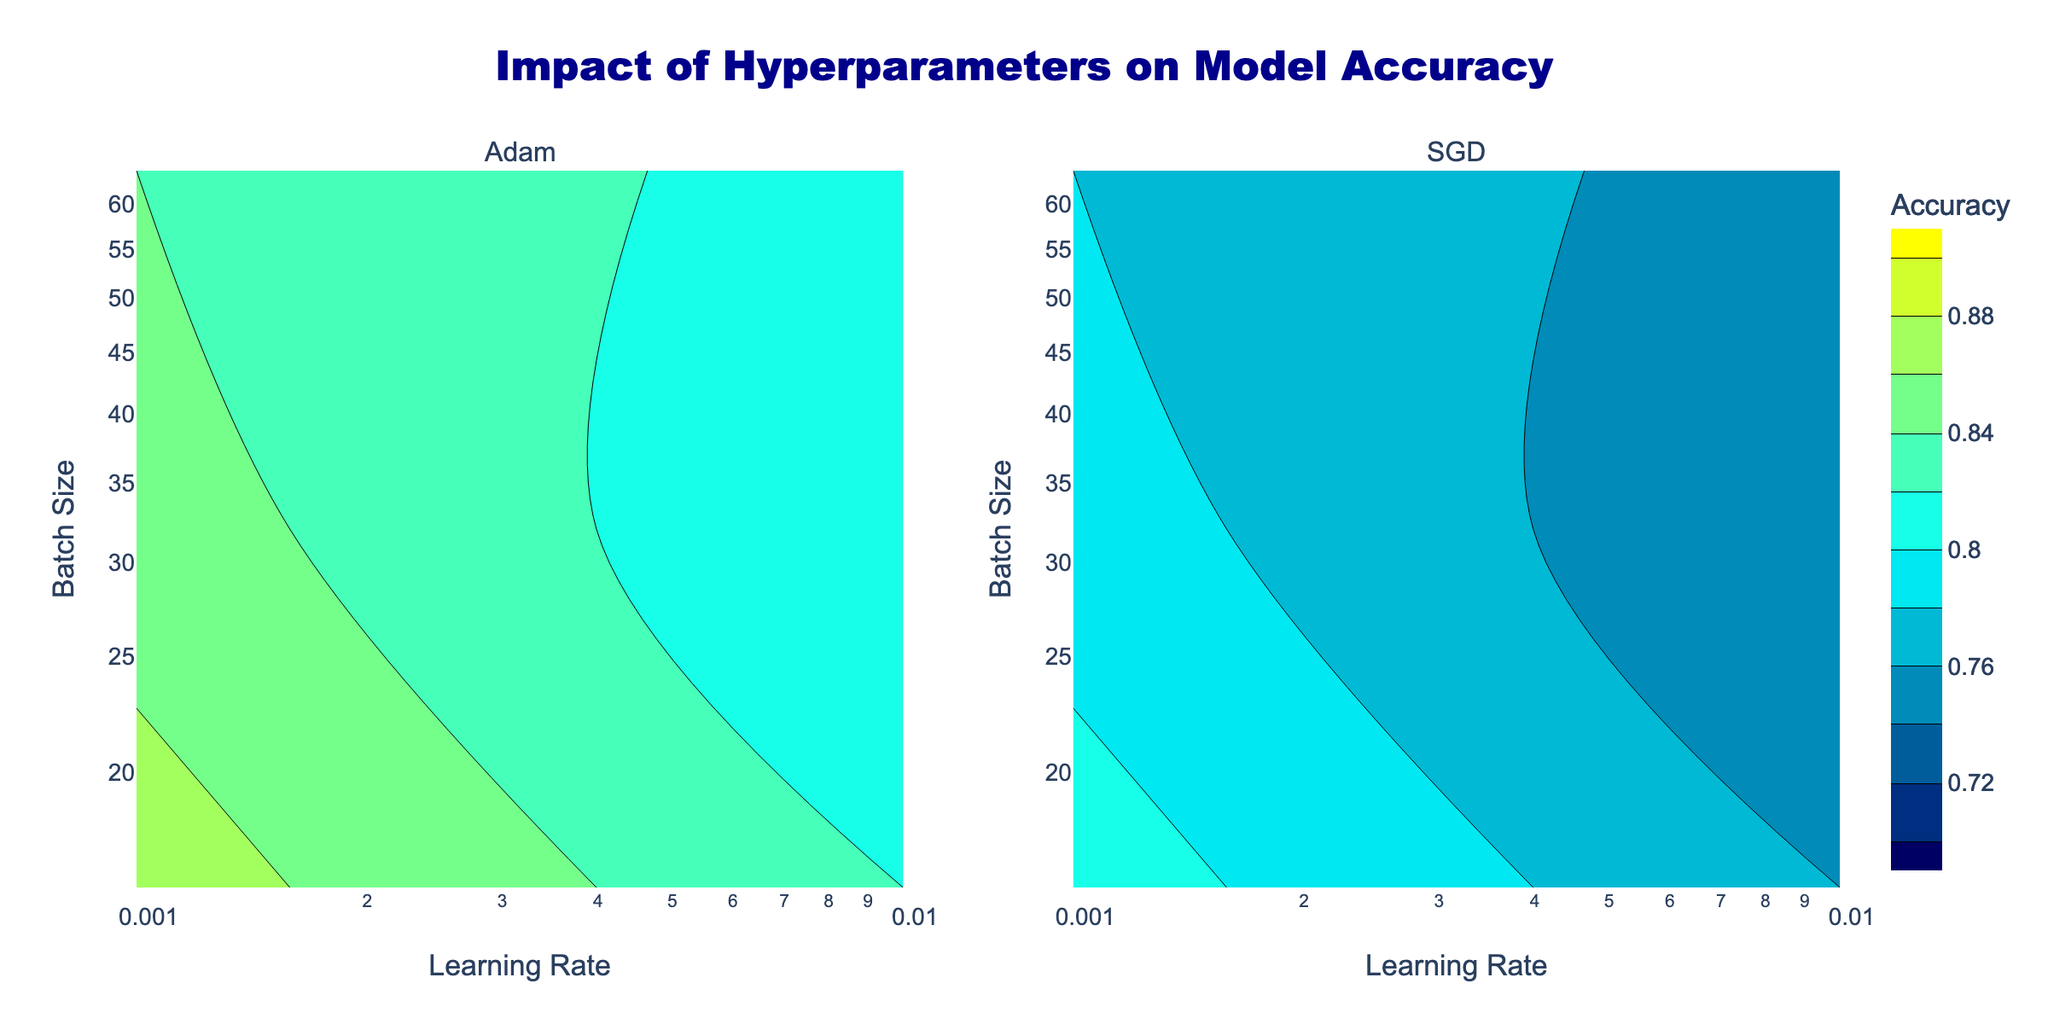What is the title of the figure? The title is located at the top center of the figure. It says "Impact of Hyperparameters on Model Accuracy".
Answer: Impact of Hyperparameters on Model Accuracy Which axis represents the learning rate? The x-axis of the figure represents the learning rate. It is clearly labeled as "Learning Rate" for both subplots.
Answer: x-axis What are the two optimizers compared in this plot? The subplot titles indicate the optimizers being compared. They are "Adam" and "SGD".
Answer: Adam, SGD What is the highest accuracy achieved for the Adam optimizer? Examining the color intensity and the contour levels for the Adam optimizer subplot, the highest accuracy contour line is 0.87.
Answer: 0.87 What's the difference in accuracy between the Adam and SGD optimizers at a learning rate of 0.001 and batch size of 16? For the learning rate of 0.001 and batch size of 16, the accuracies for Adam and SGD can be found at the points on the respective contour plots. Adam’s accuracy is 0.87 and SGD’s is 0.81. The difference is 0.87 - 0.81 = 0.06.
Answer: 0.06 Describe the color gradient used in the plot. The color gradient starts from dark blue at the bottom, transitions through cyan in the middle, and ends at yellow at the top. This gradient helps indicate different accuracy levels.
Answer: Dark blue to cyan to yellow How does the change in batch size affect the model accuracy for the Adam optimizer at a constant learning rate of 0.01? As seen in the Adam optimizer subplot, for a fixed learning rate of 0.01, increasing the batch size from 16 to 64 generally decreases the accuracy from around 0.82 to 0.81, indicating a slight drop in performance with higher batch size.
Answer: Decreases slightly Which optimizer performs better overall according to the figure? Analyzing both subplots, the Adam optimizer generally maintains higher accuracy levels compared to the SGD optimizer across the various hyperparameter settings shown.
Answer: Adam For which optimizer and hyperparameter settings is the lowest accuracy recorded? By examining the contour plots, the lowest accuracy occurs with the SGD optimizer at a learning rate of 0.01 and a batch size of 32, where the accuracy is 0.74.
Answer: SGD, 0.01 learning rate, 32 batch size 